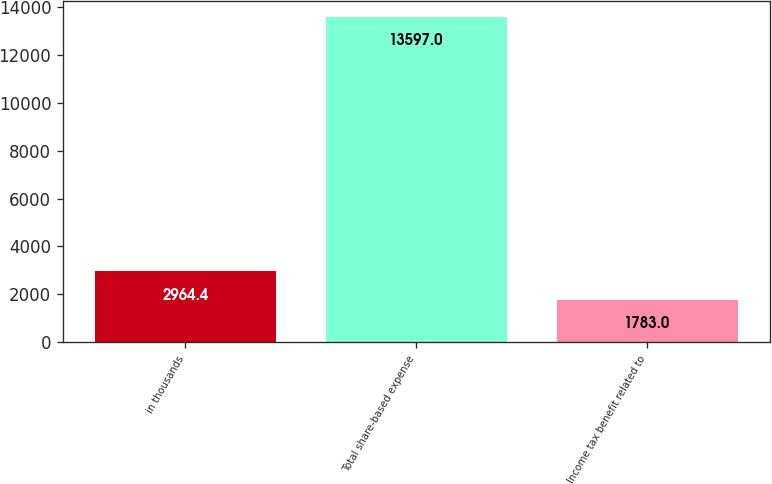<chart> <loc_0><loc_0><loc_500><loc_500><bar_chart><fcel>in thousands<fcel>Total share-based expense<fcel>Income tax benefit related to<nl><fcel>2964.4<fcel>13597<fcel>1783<nl></chart> 